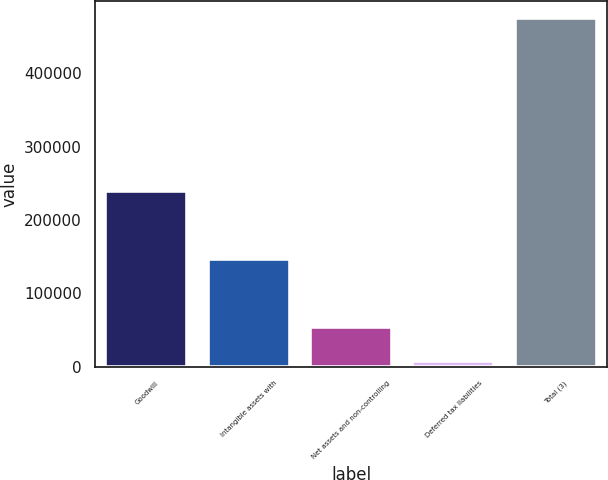<chart> <loc_0><loc_0><loc_500><loc_500><bar_chart><fcel>Goodwill<fcel>Intangible assets with<fcel>Net assets and non-controlling<fcel>Deferred tax liabilities<fcel>Total (3)<nl><fcel>239480<fcel>146126<fcel>54587.1<fcel>7910<fcel>474681<nl></chart> 